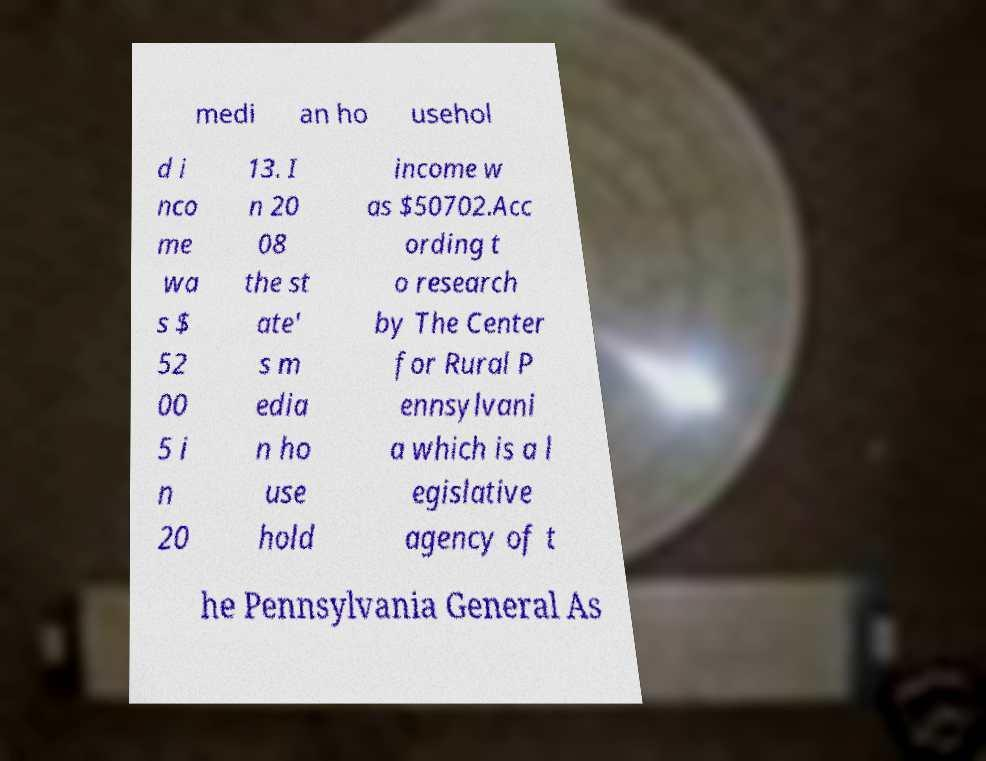I need the written content from this picture converted into text. Can you do that? medi an ho usehol d i nco me wa s $ 52 00 5 i n 20 13. I n 20 08 the st ate' s m edia n ho use hold income w as $50702.Acc ording t o research by The Center for Rural P ennsylvani a which is a l egislative agency of t he Pennsylvania General As 